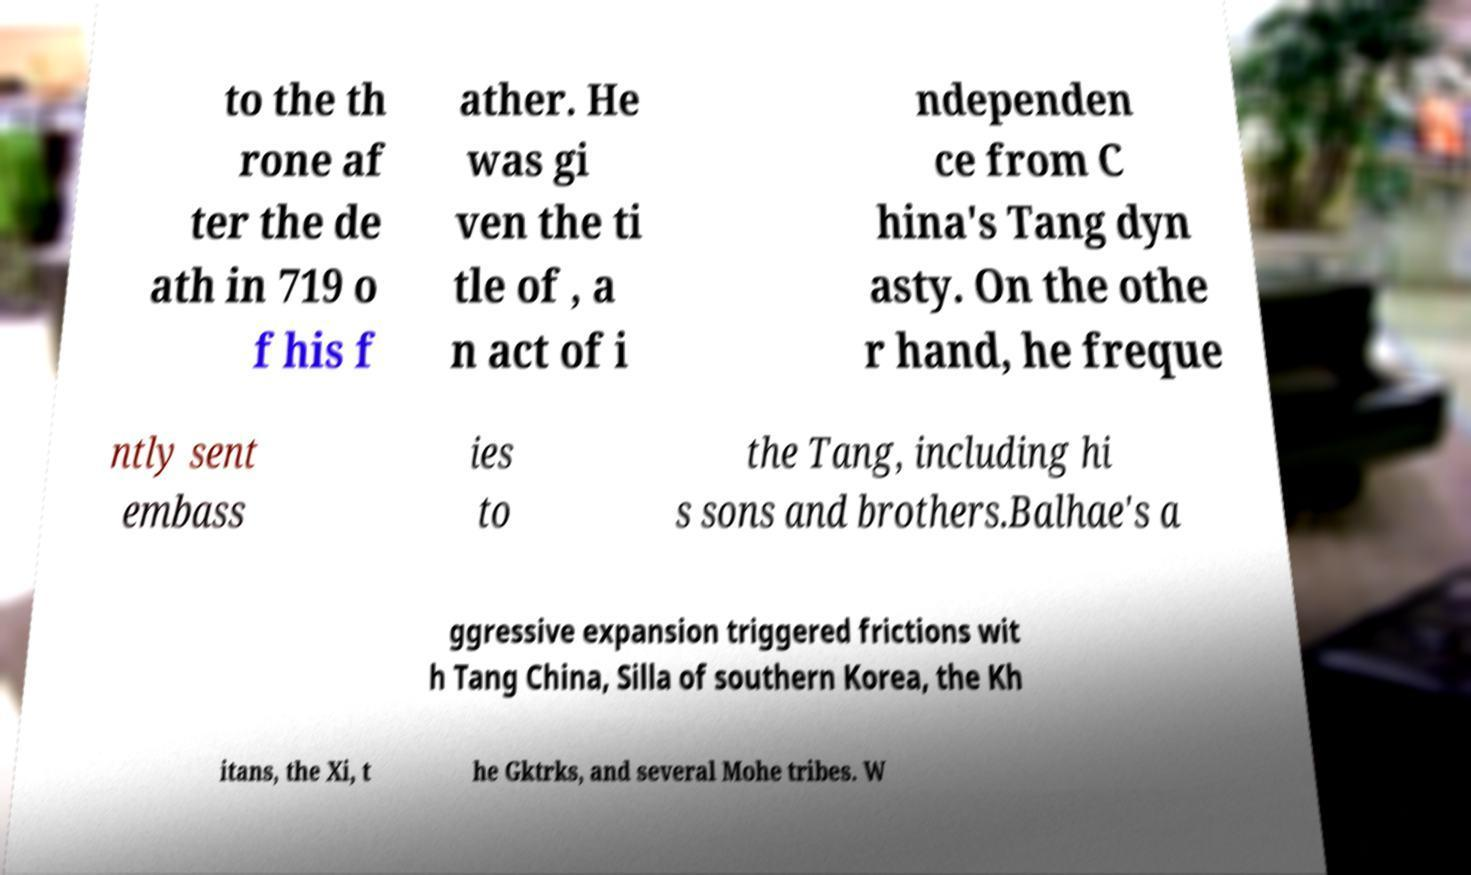What messages or text are displayed in this image? I need them in a readable, typed format. to the th rone af ter the de ath in 719 o f his f ather. He was gi ven the ti tle of , a n act of i ndependen ce from C hina's Tang dyn asty. On the othe r hand, he freque ntly sent embass ies to the Tang, including hi s sons and brothers.Balhae's a ggressive expansion triggered frictions wit h Tang China, Silla of southern Korea, the Kh itans, the Xi, t he Gktrks, and several Mohe tribes. W 